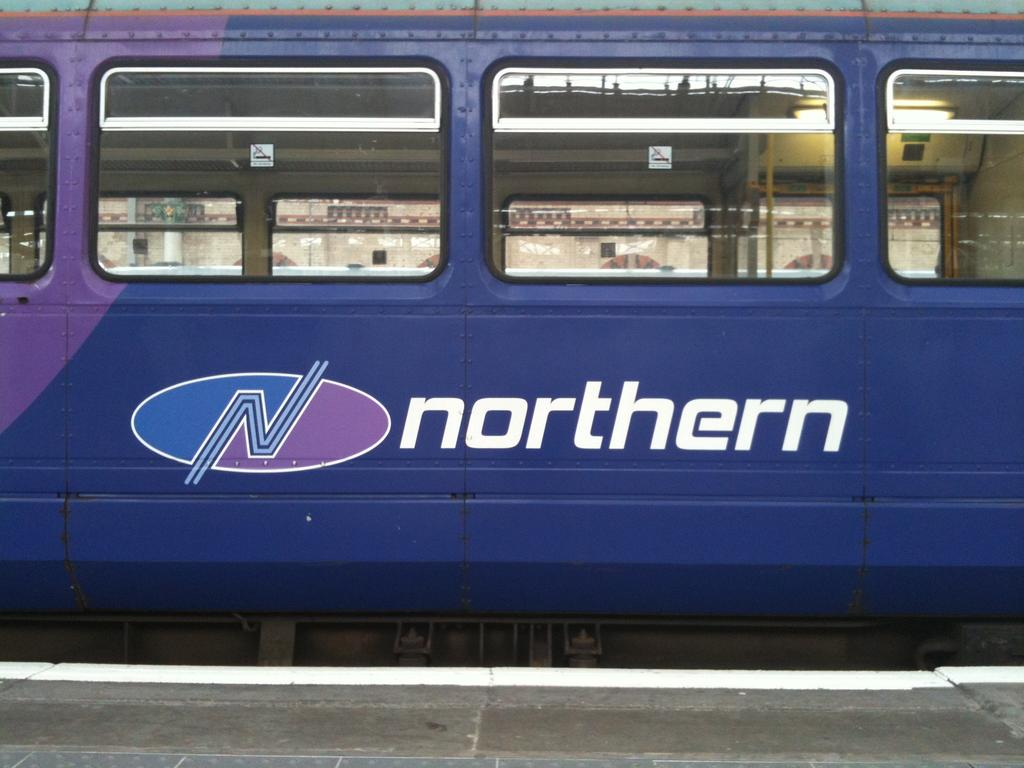What is the main subject of the image? The main subject of the image is a train. What can be seen at the top of the train? The train has windows at the top. What is written or displayed on the train? There is text visible on the train. What is located at the bottom of the image? The platform is visible at the bottom of the image. How does the train say good-bye to passengers before departing in the image? The image does not show the train saying good-bye to passengers or any indication of departure. --- 